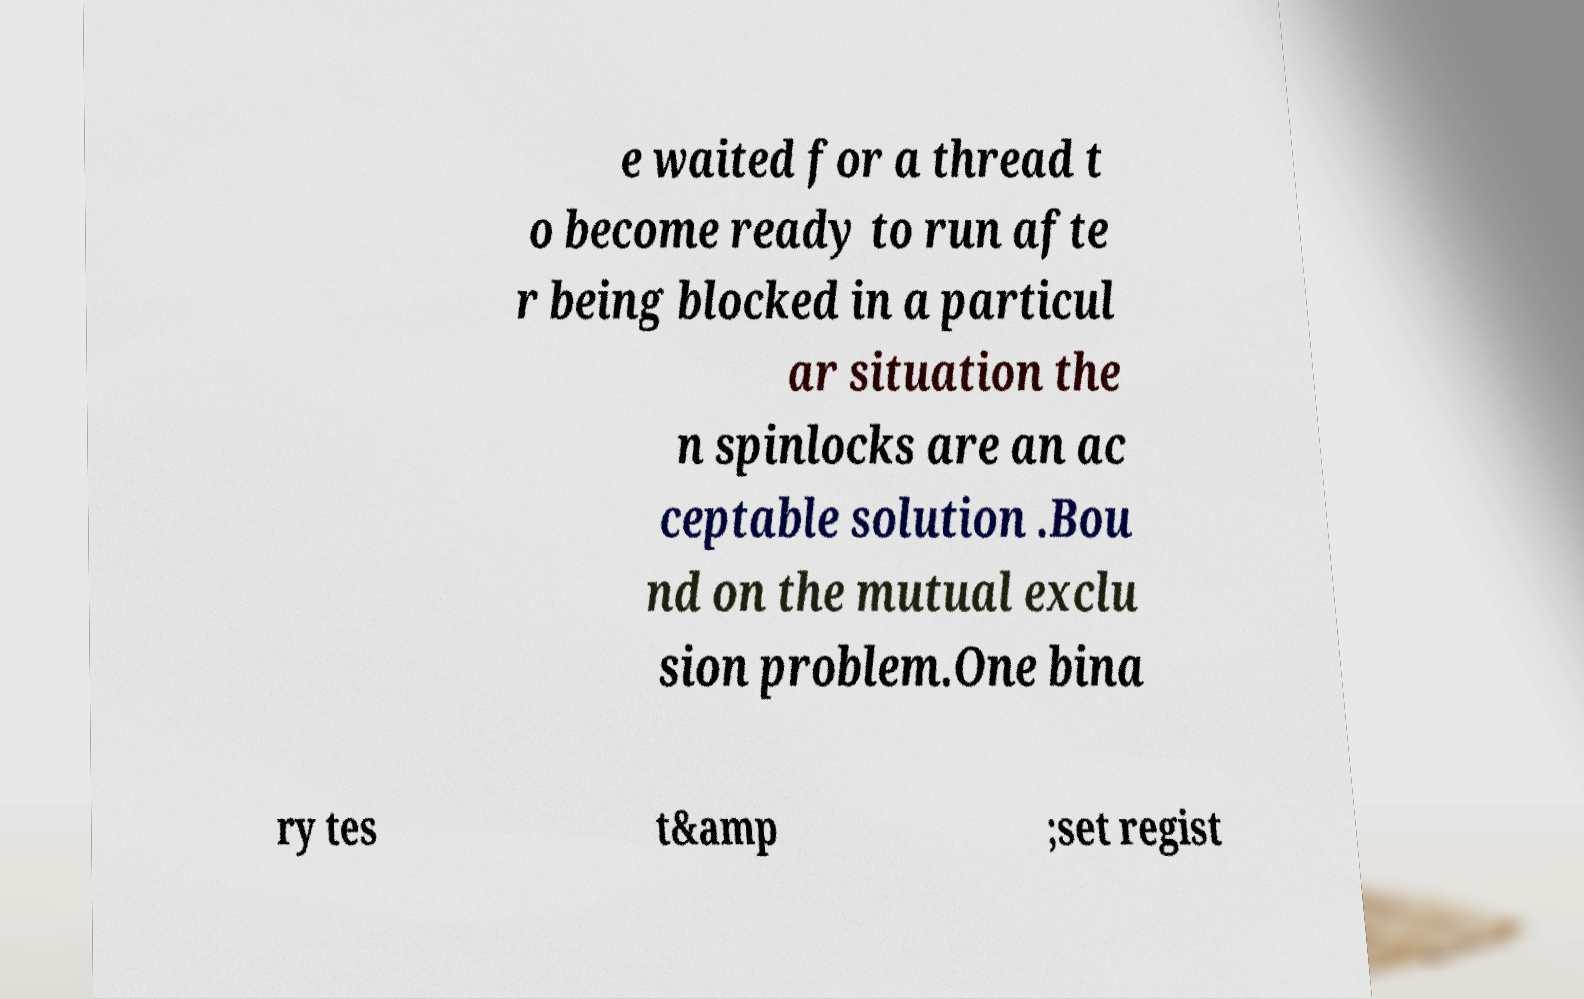For documentation purposes, I need the text within this image transcribed. Could you provide that? e waited for a thread t o become ready to run afte r being blocked in a particul ar situation the n spinlocks are an ac ceptable solution .Bou nd on the mutual exclu sion problem.One bina ry tes t&amp ;set regist 